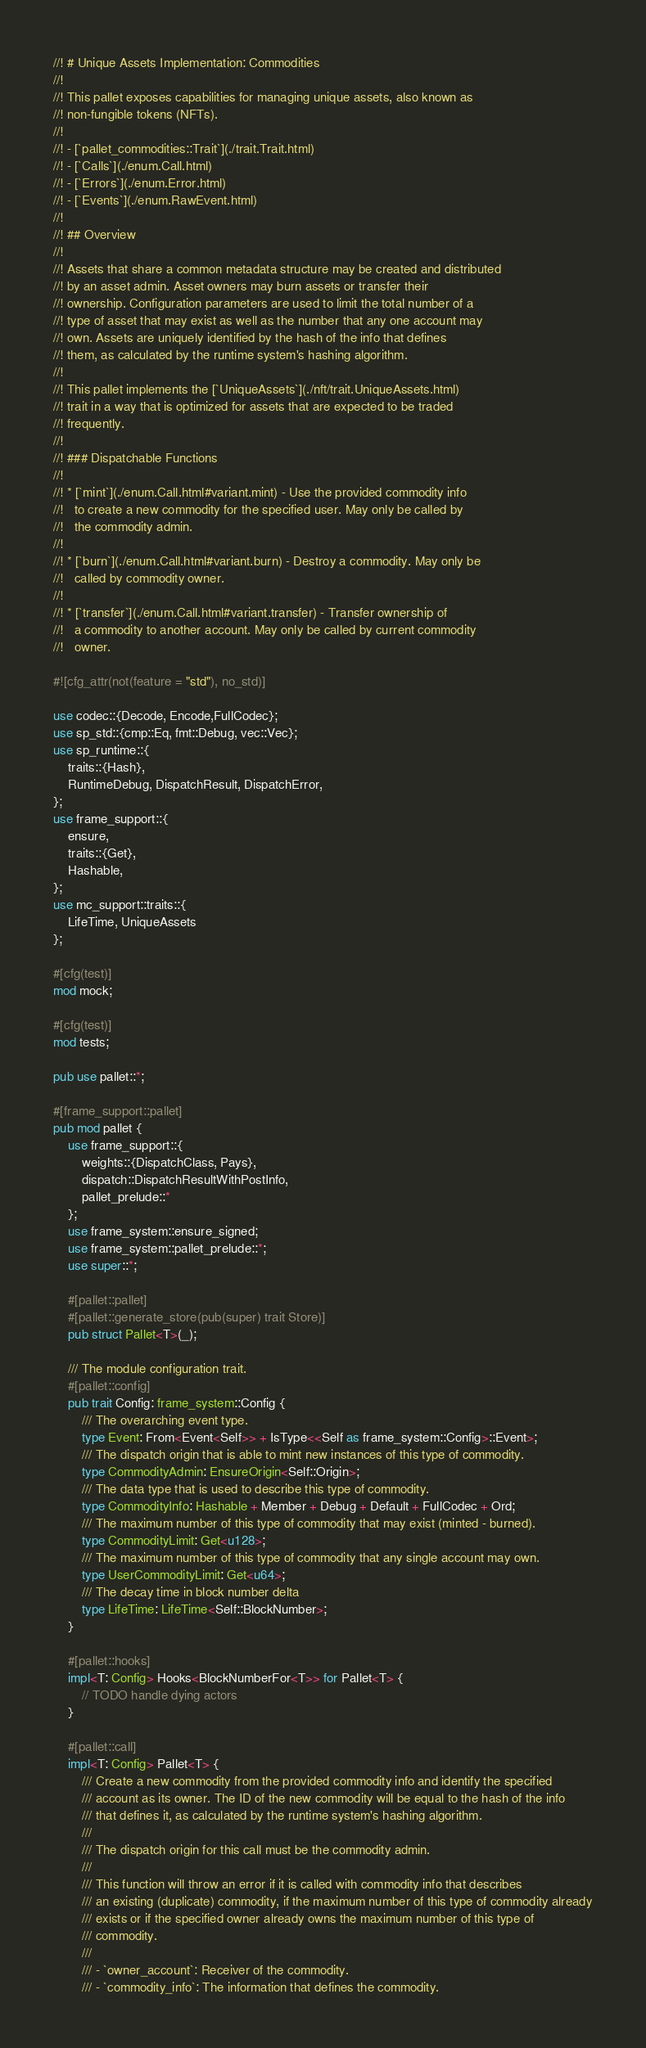Convert code to text. <code><loc_0><loc_0><loc_500><loc_500><_Rust_>//! # Unique Assets Implementation: Commodities
//!
//! This pallet exposes capabilities for managing unique assets, also known as
//! non-fungible tokens (NFTs).
//!
//! - [`pallet_commodities::Trait`](./trait.Trait.html)
//! - [`Calls`](./enum.Call.html)
//! - [`Errors`](./enum.Error.html)
//! - [`Events`](./enum.RawEvent.html)
//!
//! ## Overview
//!
//! Assets that share a common metadata structure may be created and distributed
//! by an asset admin. Asset owners may burn assets or transfer their
//! ownership. Configuration parameters are used to limit the total number of a
//! type of asset that may exist as well as the number that any one account may
//! own. Assets are uniquely identified by the hash of the info that defines
//! them, as calculated by the runtime system's hashing algorithm.
//!
//! This pallet implements the [`UniqueAssets`](./nft/trait.UniqueAssets.html)
//! trait in a way that is optimized for assets that are expected to be traded
//! frequently.
//!
//! ### Dispatchable Functions
//!
//! * [`mint`](./enum.Call.html#variant.mint) - Use the provided commodity info
//!   to create a new commodity for the specified user. May only be called by
//!   the commodity admin.
//!
//! * [`burn`](./enum.Call.html#variant.burn) - Destroy a commodity. May only be
//!   called by commodity owner.
//!
//! * [`transfer`](./enum.Call.html#variant.transfer) - Transfer ownership of
//!   a commodity to another account. May only be called by current commodity
//!   owner.

#![cfg_attr(not(feature = "std"), no_std)]

use codec::{Decode, Encode,FullCodec};
use sp_std::{cmp::Eq, fmt::Debug, vec::Vec};
use sp_runtime::{
    traits::{Hash},
    RuntimeDebug, DispatchResult, DispatchError,
};
use frame_support::{
	ensure,
	traits::{Get},
	Hashable,
};
use mc_support::traits::{
	LifeTime, UniqueAssets
};

#[cfg(test)]
mod mock;

#[cfg(test)]
mod tests;

pub use pallet::*;

#[frame_support::pallet]
pub mod pallet {
	use frame_support::{
		weights::{DispatchClass, Pays},
		dispatch::DispatchResultWithPostInfo,
		pallet_prelude::*
	};
	use frame_system::ensure_signed;
	use frame_system::pallet_prelude::*;
	use super::*;

	#[pallet::pallet]
	#[pallet::generate_store(pub(super) trait Store)]
	pub struct Pallet<T>(_);

	/// The module configuration trait.
	#[pallet::config]
	pub trait Config: frame_system::Config {
		/// The overarching event type.
		type Event: From<Event<Self>> + IsType<<Self as frame_system::Config>::Event>;
		/// The dispatch origin that is able to mint new instances of this type of commodity.
		type CommodityAdmin: EnsureOrigin<Self::Origin>;
		/// The data type that is used to describe this type of commodity.
		type CommodityInfo: Hashable + Member + Debug + Default + FullCodec + Ord;
		/// The maximum number of this type of commodity that may exist (minted - burned).
		type CommodityLimit: Get<u128>;
		/// The maximum number of this type of commodity that any single account may own.
		type UserCommodityLimit: Get<u64>;
		/// The decay time in block number delta
		type LifeTime: LifeTime<Self::BlockNumber>;
	}

	#[pallet::hooks]
	impl<T: Config> Hooks<BlockNumberFor<T>> for Pallet<T> {
		// TODO handle dying actors
	}

	#[pallet::call]
	impl<T: Config> Pallet<T> {
        /// Create a new commodity from the provided commodity info and identify the specified
        /// account as its owner. The ID of the new commodity will be equal to the hash of the info
        /// that defines it, as calculated by the runtime system's hashing algorithm.
        ///
        /// The dispatch origin for this call must be the commodity admin.
        ///
        /// This function will throw an error if it is called with commodity info that describes
        /// an existing (duplicate) commodity, if the maximum number of this type of commodity already
        /// exists or if the specified owner already owns the maximum number of this type of
        /// commodity.
        ///
        /// - `owner_account`: Receiver of the commodity.
        /// - `commodity_info`: The information that defines the commodity.</code> 